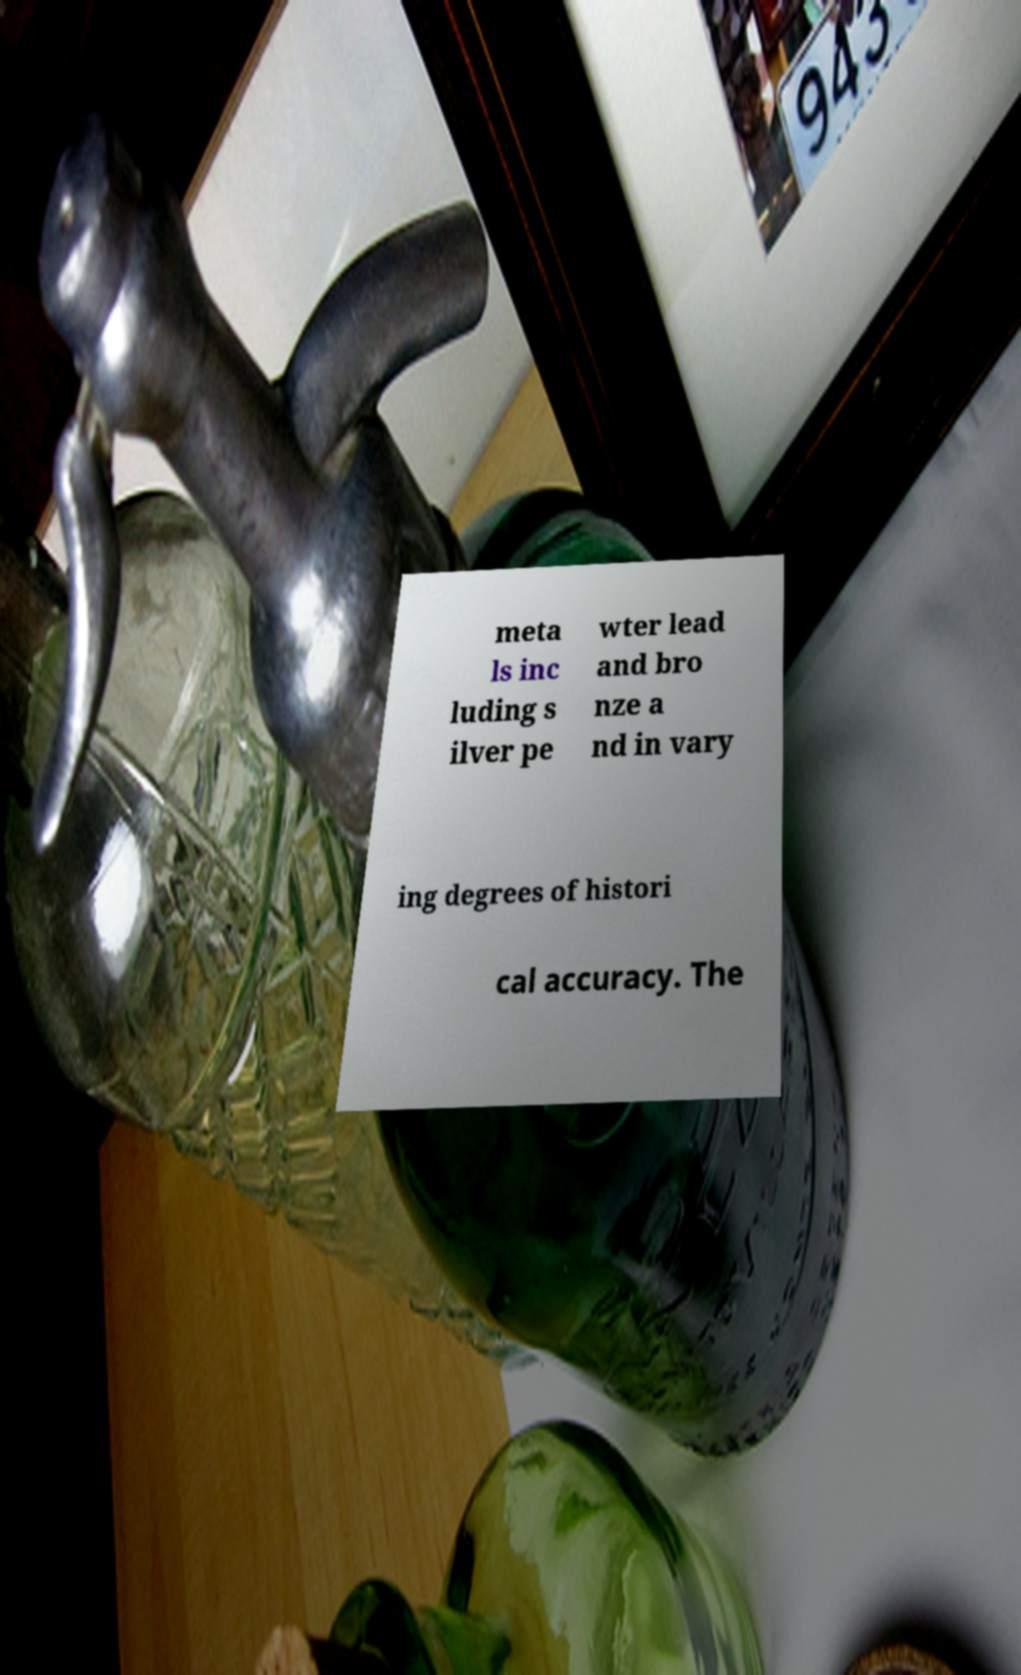What messages or text are displayed in this image? I need them in a readable, typed format. meta ls inc luding s ilver pe wter lead and bro nze a nd in vary ing degrees of histori cal accuracy. The 